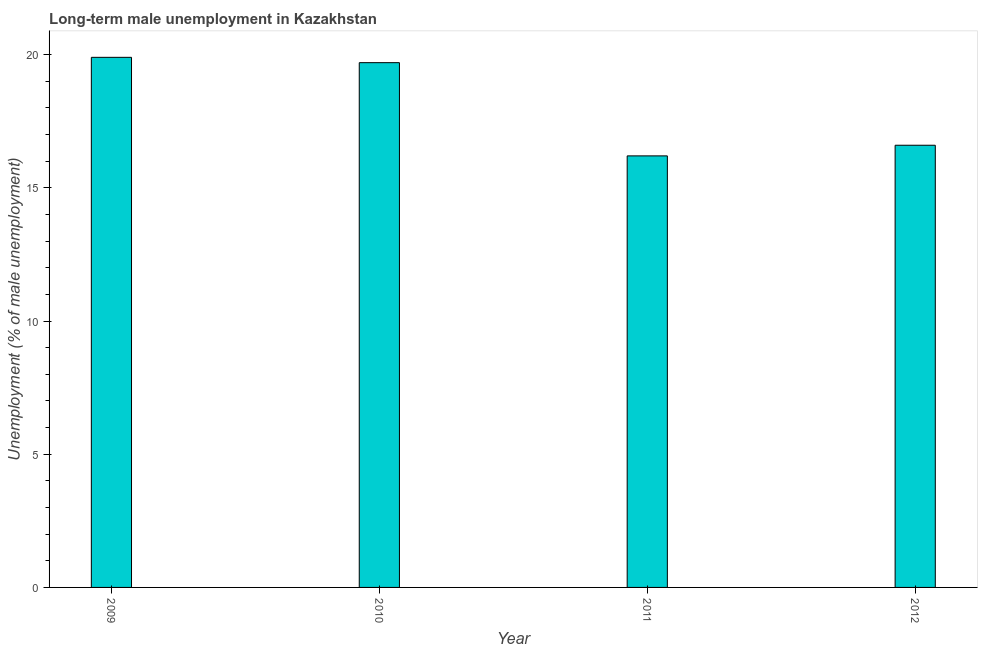What is the title of the graph?
Offer a very short reply. Long-term male unemployment in Kazakhstan. What is the label or title of the X-axis?
Give a very brief answer. Year. What is the label or title of the Y-axis?
Make the answer very short. Unemployment (% of male unemployment). What is the long-term male unemployment in 2010?
Your answer should be compact. 19.7. Across all years, what is the maximum long-term male unemployment?
Make the answer very short. 19.9. Across all years, what is the minimum long-term male unemployment?
Make the answer very short. 16.2. In which year was the long-term male unemployment maximum?
Your answer should be very brief. 2009. What is the sum of the long-term male unemployment?
Your answer should be compact. 72.4. What is the difference between the long-term male unemployment in 2009 and 2010?
Provide a short and direct response. 0.2. What is the median long-term male unemployment?
Offer a very short reply. 18.15. What is the ratio of the long-term male unemployment in 2010 to that in 2011?
Your answer should be compact. 1.22. Is the long-term male unemployment in 2009 less than that in 2010?
Your answer should be compact. No. Is the difference between the long-term male unemployment in 2009 and 2012 greater than the difference between any two years?
Provide a short and direct response. No. What is the difference between the highest and the second highest long-term male unemployment?
Offer a terse response. 0.2. Is the sum of the long-term male unemployment in 2010 and 2012 greater than the maximum long-term male unemployment across all years?
Provide a succinct answer. Yes. How many bars are there?
Ensure brevity in your answer.  4. How many years are there in the graph?
Ensure brevity in your answer.  4. What is the difference between two consecutive major ticks on the Y-axis?
Keep it short and to the point. 5. What is the Unemployment (% of male unemployment) in 2009?
Provide a succinct answer. 19.9. What is the Unemployment (% of male unemployment) of 2010?
Make the answer very short. 19.7. What is the Unemployment (% of male unemployment) of 2011?
Offer a very short reply. 16.2. What is the Unemployment (% of male unemployment) of 2012?
Give a very brief answer. 16.6. What is the difference between the Unemployment (% of male unemployment) in 2011 and 2012?
Offer a terse response. -0.4. What is the ratio of the Unemployment (% of male unemployment) in 2009 to that in 2011?
Your response must be concise. 1.23. What is the ratio of the Unemployment (% of male unemployment) in 2009 to that in 2012?
Offer a terse response. 1.2. What is the ratio of the Unemployment (% of male unemployment) in 2010 to that in 2011?
Provide a succinct answer. 1.22. What is the ratio of the Unemployment (% of male unemployment) in 2010 to that in 2012?
Your response must be concise. 1.19. What is the ratio of the Unemployment (% of male unemployment) in 2011 to that in 2012?
Your response must be concise. 0.98. 